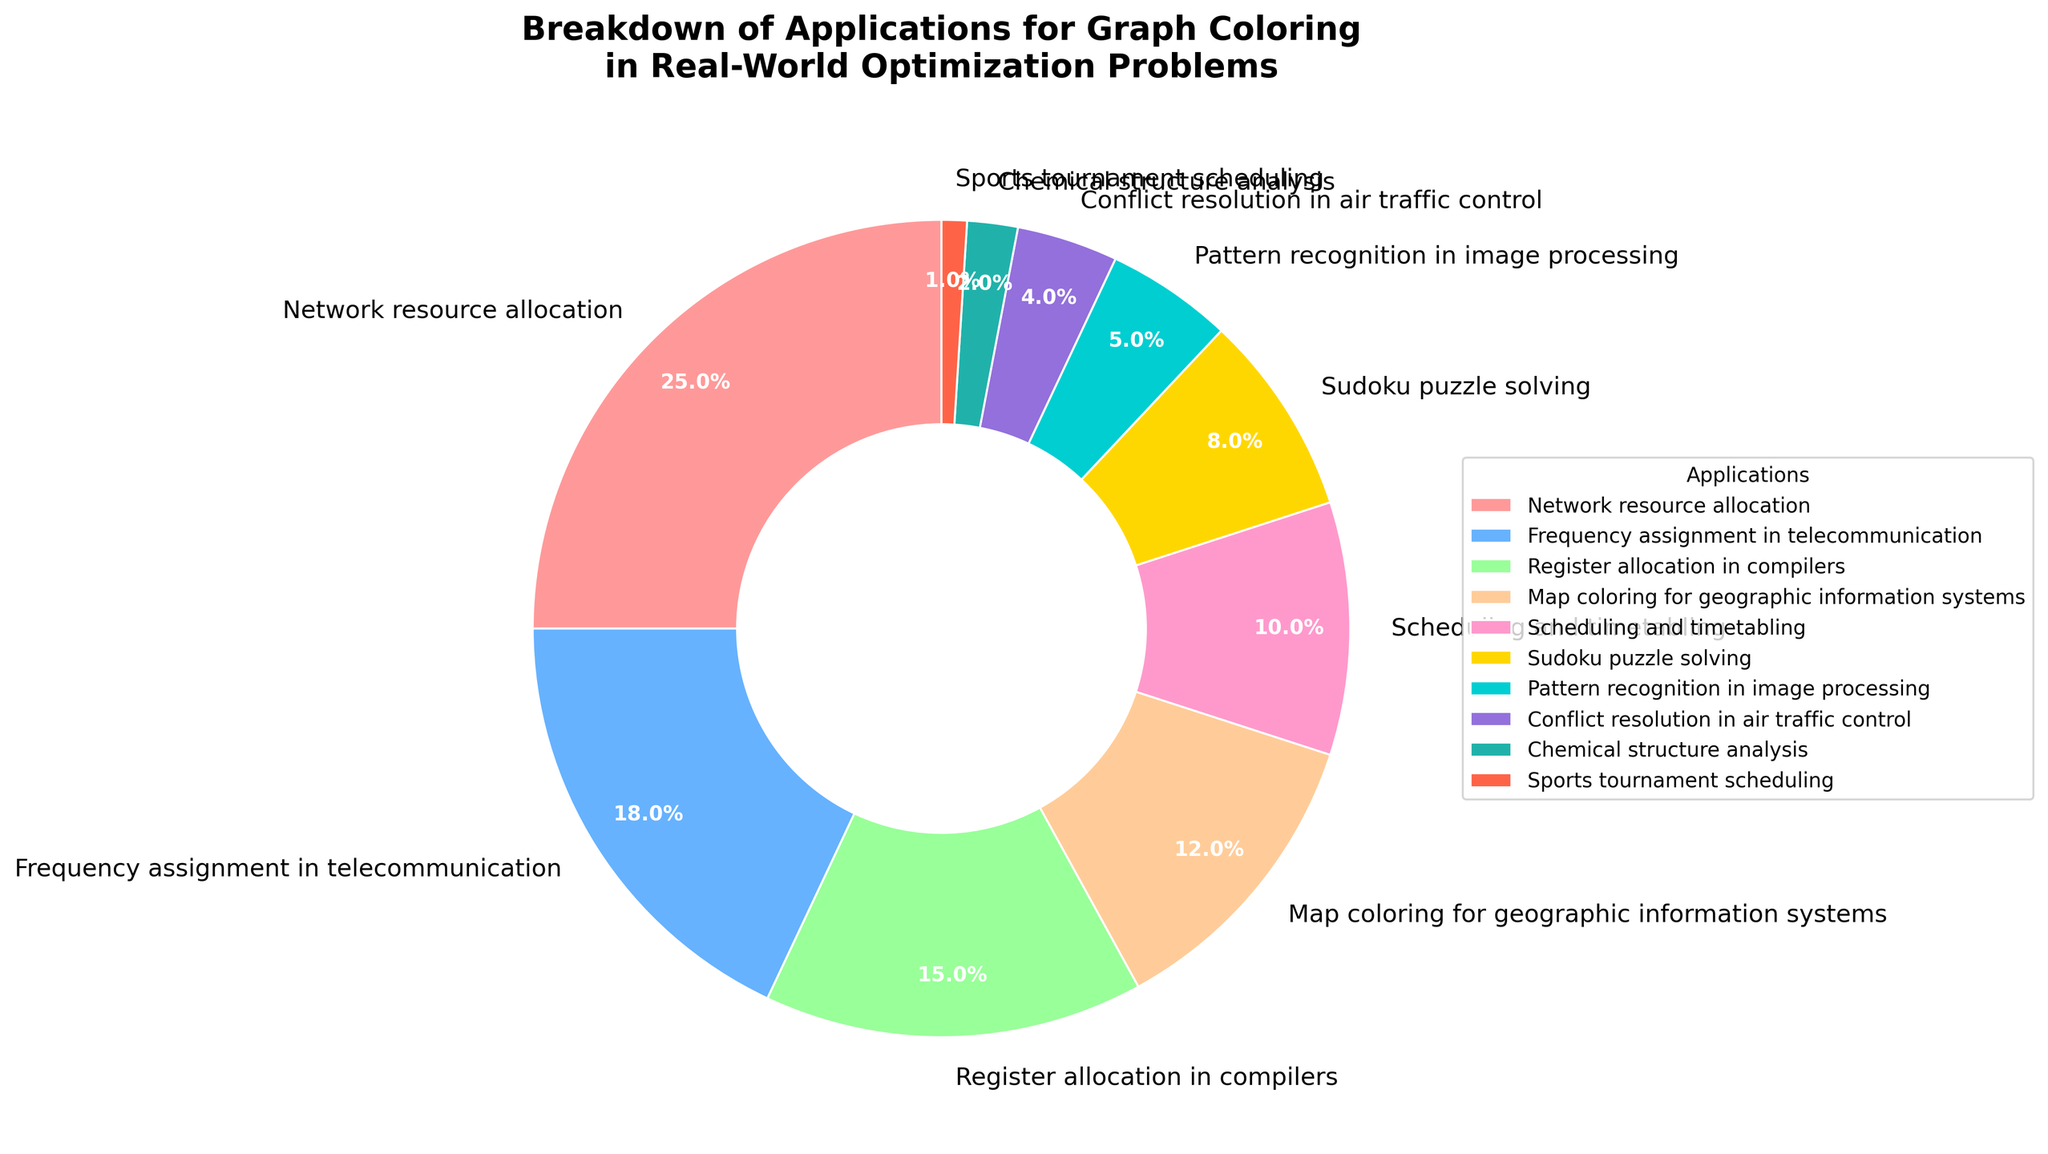What percentage of applications does 'Network resource allocation' constitute? Looking at the pie chart, locate the segment labeled 'Network resource allocation' and see the percentage written inside or next to it.
Answer: 25% Which application has the smallest representation in the pie chart? Identify the segment with the smallest slice of the pie chart. This represents the application with the smallest percentage.
Answer: Sports tournament scheduling What is the sum of the percentages for 'Register allocation in compilers' and 'Map coloring for geographic information systems'? Locate the segments for 'Register allocation in compilers' and 'Map coloring for geographic information systems'. Add their respective percentages: 15% and 12%. Thus, 15 + 12 = 27.
Answer: 27% Which application has a larger percentage: 'Scheduling and timetabling' or 'Sudoku puzzle solving'? Compare the segments labeled 'Scheduling and timetabling' and 'Sudoku puzzle solving'. Identify the percentages associated with each and note which one is larger.
Answer: Scheduling and timetabling How much larger is the percentage of 'Frequency assignment in telecommunication' compared to 'Chemical structure analysis'? Subtract the percentage of 'Chemical structure analysis' from 'Frequency assignment in telecommunication': 18% - 2% = 16%.
Answer: 16% What is the combined percentage of all applications except the top three? First, identify the top three applications based on their percentages: 'Network resource allocation' (25%), 'Frequency assignment in telecommunication' (18%), and 'Register allocation in compilers' (15%). Total their percentages: 25 + 18 + 15 = 58%. Subtract this from 100% (the total): 100 - 58 = 42%.
Answer: 42% How many applications constitute less than 10% each? Identify segments with percentages less than 10% and count them: 'Scheduling and timetabling' (10%), 'Sudoku puzzle solving' (8%), 'Pattern recognition in image processing' (5%), 'Conflict resolution in air traffic control' (4%), 'Chemical structure analysis' (2%), 'Sports tournament scheduling' (1%).
Answer: 6 Is the percentage for 'Pattern recognition in image processing' greater than, less than, or equal to that for 'Chemical structure analysis'? Compare the segments labeled 'Pattern recognition in image processing' and 'Chemical structure analysis' by their percentages: 5% for pattern recognition and 2% for chemical structure.
Answer: Greater than What is the average percentage for the applications: 'Network resource allocation', 'Frequency assignment in telecommunication', and 'Register allocation in compilers'? Sum the percentages of these three applications and divide by 3. Sum: 25 + 18 + 15 = 58. Average: 58/3 ≈ 19.33%.
Answer: 19.33% What color represents 'Sudoku puzzle solving' in the pie chart? Identify the segment labeled 'Sudoku puzzle solving' and note its color in the pie chart.
Answer: Yellow (assuming '#FFD700' which is commonly yellow/gold) 